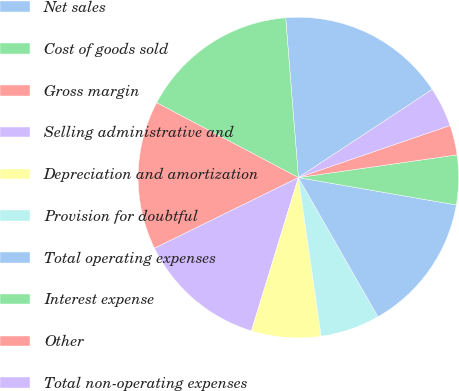Convert chart to OTSL. <chart><loc_0><loc_0><loc_500><loc_500><pie_chart><fcel>Net sales<fcel>Cost of goods sold<fcel>Gross margin<fcel>Selling administrative and<fcel>Depreciation and amortization<fcel>Provision for doubtful<fcel>Total operating expenses<fcel>Interest expense<fcel>Other<fcel>Total non-operating expenses<nl><fcel>17.0%<fcel>16.0%<fcel>15.0%<fcel>13.0%<fcel>7.0%<fcel>6.0%<fcel>14.0%<fcel>5.0%<fcel>3.0%<fcel>4.0%<nl></chart> 